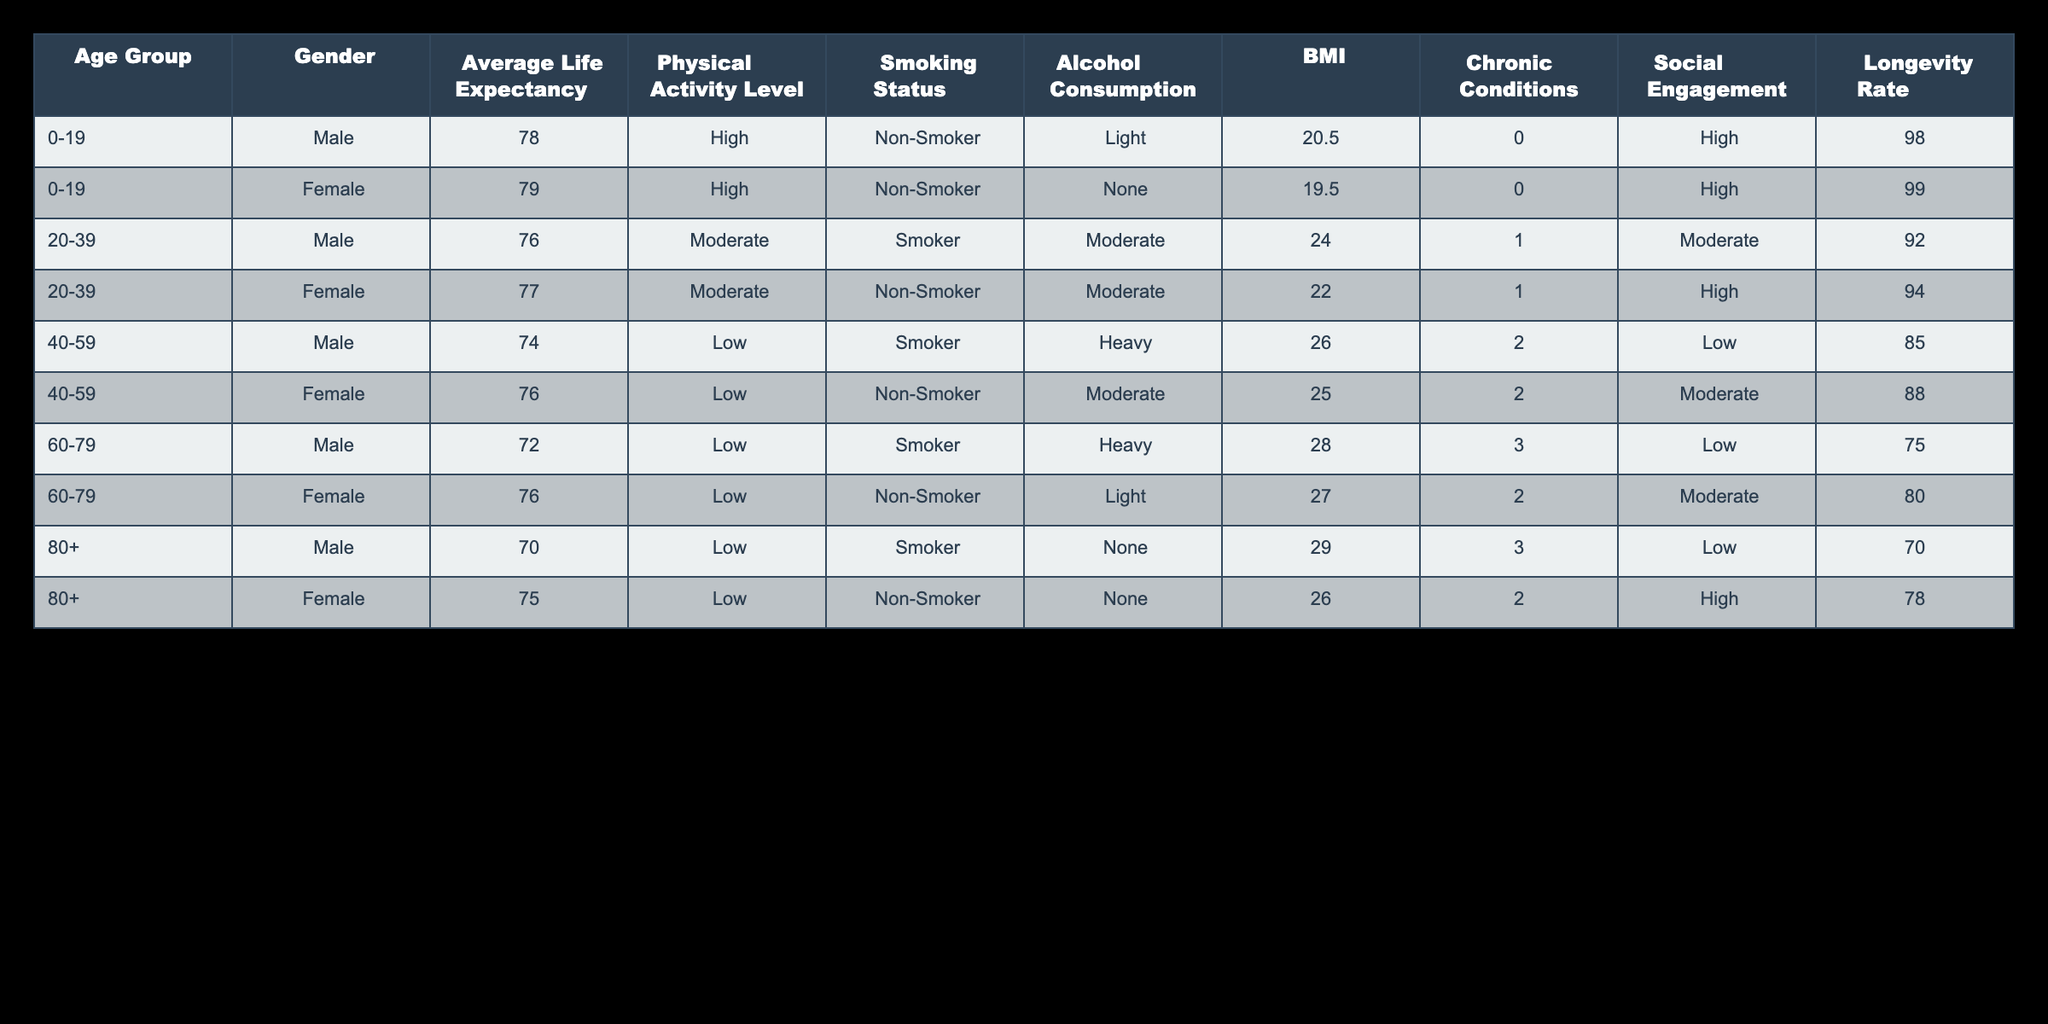What is the average life expectancy for females in the 80+ age group? From the table, we can see that for the age group 80+, the life expectancy for females is 75. There is only one entry for females in that age group. Therefore, the average life expectancy is simply the value given for that entry, which is 75.
Answer: 75 What is the longevity rate for males aged 40-59 who smoke? Looking at the age group 40-59, there is one male entry with the smoking status marked as a smoker. The entry shows that the longevity rate is 85. Therefore, the answer is directly taken from that entry.
Answer: 85 Do non-smokers generally have a higher longevity rate than smokers in the 20-39 age group? In the 20-39 age group, the longevity rates are 92 for males (smoker) and 94 for females (non-smoker). Since 94 > 92, we can conclude that non-smokers have a higher longevity rate in this age group.
Answer: Yes What is the difference in longevity rates between males and females in the 60-79 age group? For males in the 60-79 age group, the longevity rate is 75, while for females, it is 80. The difference in longevity rates is calculated by subtracting the male longevity rate from the female longevity rate: 80 - 75 = 5.
Answer: 5 Are there any individuals in the table who have "High" social engagement and a "Low" physical activity level? By examining the entries, we can see that all individuals with "High" social engagement are in the age groups 0-19 (both genders) and 80+ (females) and have "High" or "Moderate" physical activity levels. Therefore, there are no individuals with both "High" social engagement and "Low" physical activity level.
Answer: No What is the average BMI for females in the 40-59 age group? There are two female entries in the 40-59 age group with BMIs of 25.0 and 26.0. To calculate the average, we sum the BMI values and divide by the count: (25.0 + 26.0) / 2 = 25.5. Hence, the average BMI for females in this age group is 25.5.
Answer: 25.5 Which age group has the lowest longevity rate among males? From the table, the longevity rates for males are 98 (0-19), 92 (20-39), 85 (40-59), 75 (60-79), and 70 (80+). The lowest longevity rate among these entries is 70, which corresponds to the 80+ age group.
Answer: 80+ 